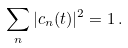Convert formula to latex. <formula><loc_0><loc_0><loc_500><loc_500>\sum _ { n } | c _ { n } ( t ) | ^ { 2 } = 1 \, .</formula> 